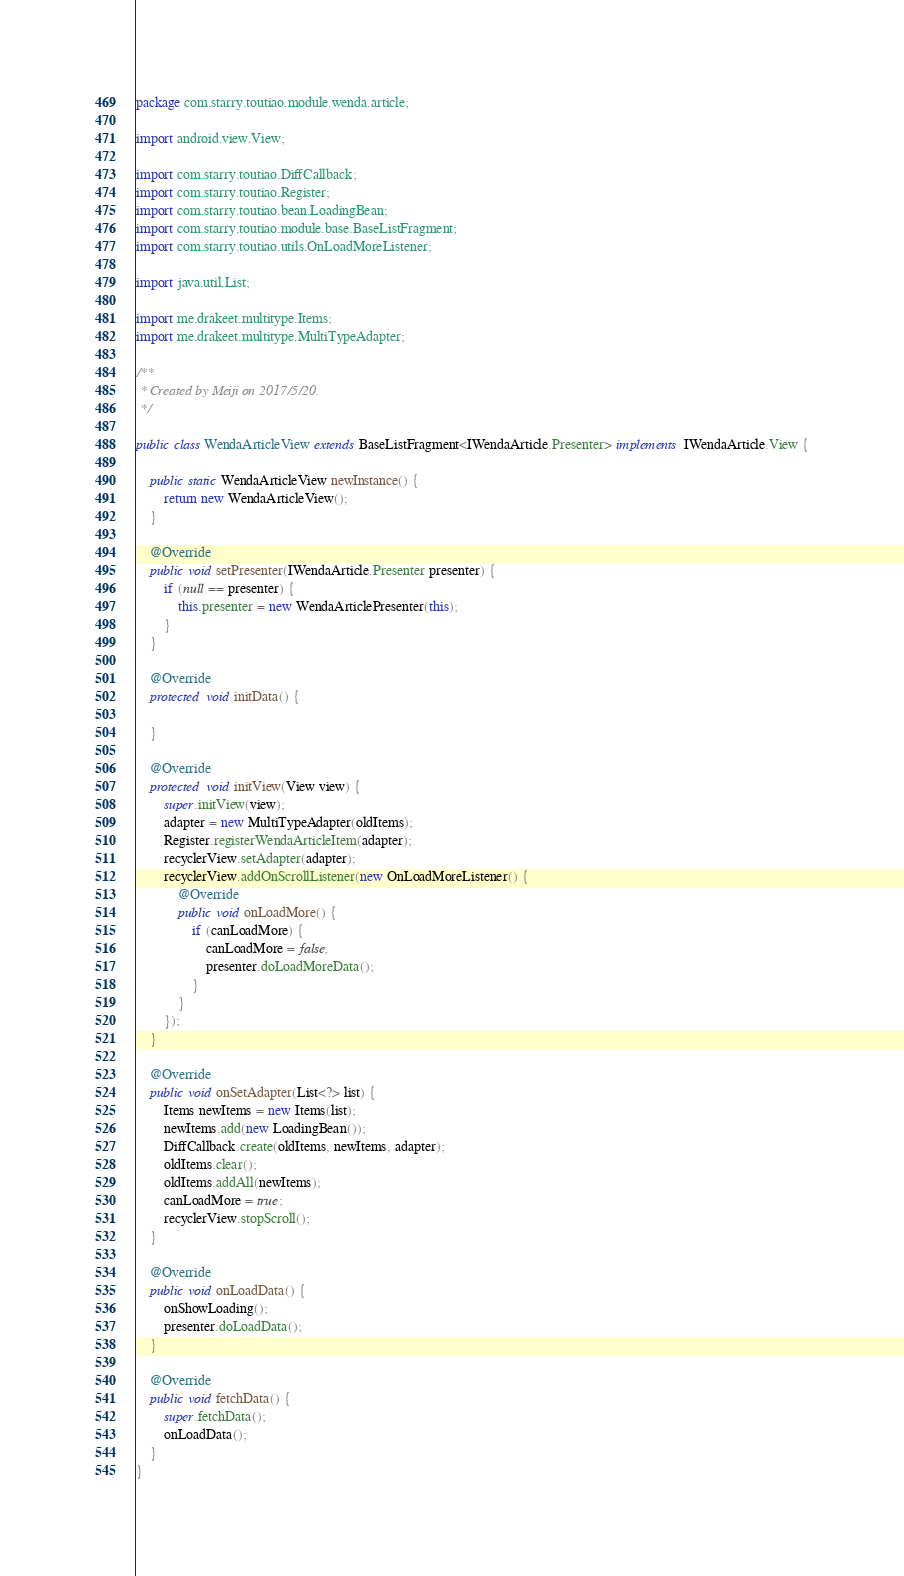Convert code to text. <code><loc_0><loc_0><loc_500><loc_500><_Java_>package com.starry.toutiao.module.wenda.article;

import android.view.View;

import com.starry.toutiao.DiffCallback;
import com.starry.toutiao.Register;
import com.starry.toutiao.bean.LoadingBean;
import com.starry.toutiao.module.base.BaseListFragment;
import com.starry.toutiao.utils.OnLoadMoreListener;

import java.util.List;

import me.drakeet.multitype.Items;
import me.drakeet.multitype.MultiTypeAdapter;

/**
 * Created by Meiji on 2017/5/20.
 */

public class WendaArticleView extends BaseListFragment<IWendaArticle.Presenter> implements IWendaArticle.View {

    public static WendaArticleView newInstance() {
        return new WendaArticleView();
    }

    @Override
    public void setPresenter(IWendaArticle.Presenter presenter) {
        if (null == presenter) {
            this.presenter = new WendaArticlePresenter(this);
        }
    }

    @Override
    protected void initData() {

    }

    @Override
    protected void initView(View view) {
        super.initView(view);
        adapter = new MultiTypeAdapter(oldItems);
        Register.registerWendaArticleItem(adapter);
        recyclerView.setAdapter(adapter);
        recyclerView.addOnScrollListener(new OnLoadMoreListener() {
            @Override
            public void onLoadMore() {
                if (canLoadMore) {
                    canLoadMore = false;
                    presenter.doLoadMoreData();
                }
            }
        });
    }

    @Override
    public void onSetAdapter(List<?> list) {
        Items newItems = new Items(list);
        newItems.add(new LoadingBean());
        DiffCallback.create(oldItems, newItems, adapter);
        oldItems.clear();
        oldItems.addAll(newItems);
        canLoadMore = true;
        recyclerView.stopScroll();
    }

    @Override
    public void onLoadData() {
        onShowLoading();
        presenter.doLoadData();
    }

    @Override
    public void fetchData() {
        super.fetchData();
        onLoadData();
    }
}
</code> 